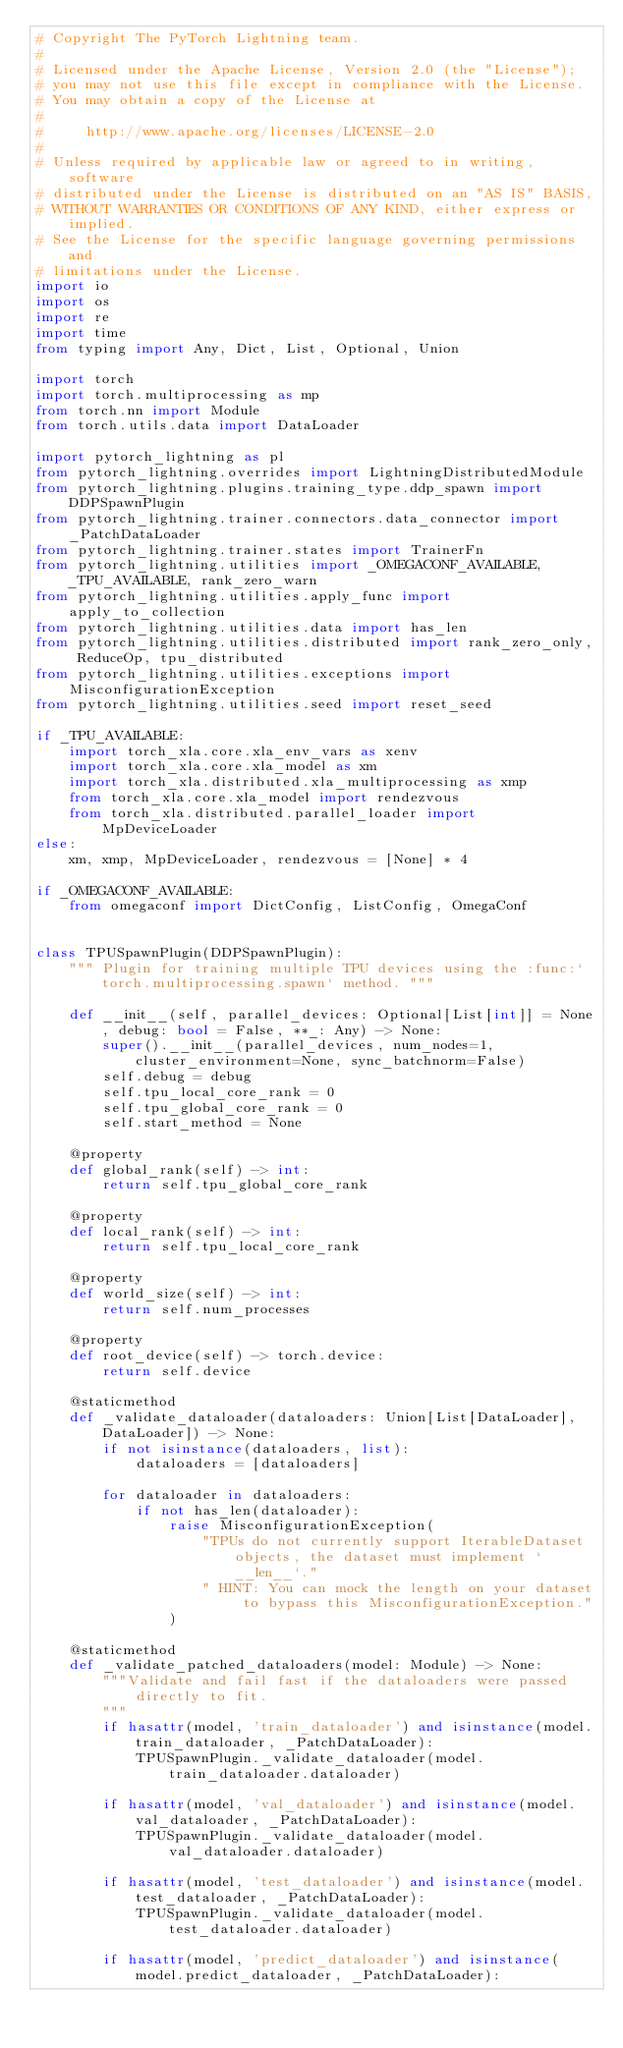<code> <loc_0><loc_0><loc_500><loc_500><_Python_># Copyright The PyTorch Lightning team.
#
# Licensed under the Apache License, Version 2.0 (the "License");
# you may not use this file except in compliance with the License.
# You may obtain a copy of the License at
#
#     http://www.apache.org/licenses/LICENSE-2.0
#
# Unless required by applicable law or agreed to in writing, software
# distributed under the License is distributed on an "AS IS" BASIS,
# WITHOUT WARRANTIES OR CONDITIONS OF ANY KIND, either express or implied.
# See the License for the specific language governing permissions and
# limitations under the License.
import io
import os
import re
import time
from typing import Any, Dict, List, Optional, Union

import torch
import torch.multiprocessing as mp
from torch.nn import Module
from torch.utils.data import DataLoader

import pytorch_lightning as pl
from pytorch_lightning.overrides import LightningDistributedModule
from pytorch_lightning.plugins.training_type.ddp_spawn import DDPSpawnPlugin
from pytorch_lightning.trainer.connectors.data_connector import _PatchDataLoader
from pytorch_lightning.trainer.states import TrainerFn
from pytorch_lightning.utilities import _OMEGACONF_AVAILABLE, _TPU_AVAILABLE, rank_zero_warn
from pytorch_lightning.utilities.apply_func import apply_to_collection
from pytorch_lightning.utilities.data import has_len
from pytorch_lightning.utilities.distributed import rank_zero_only, ReduceOp, tpu_distributed
from pytorch_lightning.utilities.exceptions import MisconfigurationException
from pytorch_lightning.utilities.seed import reset_seed

if _TPU_AVAILABLE:
    import torch_xla.core.xla_env_vars as xenv
    import torch_xla.core.xla_model as xm
    import torch_xla.distributed.xla_multiprocessing as xmp
    from torch_xla.core.xla_model import rendezvous
    from torch_xla.distributed.parallel_loader import MpDeviceLoader
else:
    xm, xmp, MpDeviceLoader, rendezvous = [None] * 4

if _OMEGACONF_AVAILABLE:
    from omegaconf import DictConfig, ListConfig, OmegaConf


class TPUSpawnPlugin(DDPSpawnPlugin):
    """ Plugin for training multiple TPU devices using the :func:`torch.multiprocessing.spawn` method. """

    def __init__(self, parallel_devices: Optional[List[int]] = None, debug: bool = False, **_: Any) -> None:
        super().__init__(parallel_devices, num_nodes=1, cluster_environment=None, sync_batchnorm=False)
        self.debug = debug
        self.tpu_local_core_rank = 0
        self.tpu_global_core_rank = 0
        self.start_method = None

    @property
    def global_rank(self) -> int:
        return self.tpu_global_core_rank

    @property
    def local_rank(self) -> int:
        return self.tpu_local_core_rank

    @property
    def world_size(self) -> int:
        return self.num_processes

    @property
    def root_device(self) -> torch.device:
        return self.device

    @staticmethod
    def _validate_dataloader(dataloaders: Union[List[DataLoader], DataLoader]) -> None:
        if not isinstance(dataloaders, list):
            dataloaders = [dataloaders]

        for dataloader in dataloaders:
            if not has_len(dataloader):
                raise MisconfigurationException(
                    "TPUs do not currently support IterableDataset objects, the dataset must implement `__len__`."
                    " HINT: You can mock the length on your dataset to bypass this MisconfigurationException."
                )

    @staticmethod
    def _validate_patched_dataloaders(model: Module) -> None:
        """Validate and fail fast if the dataloaders were passed directly to fit.
        """
        if hasattr(model, 'train_dataloader') and isinstance(model.train_dataloader, _PatchDataLoader):
            TPUSpawnPlugin._validate_dataloader(model.train_dataloader.dataloader)

        if hasattr(model, 'val_dataloader') and isinstance(model.val_dataloader, _PatchDataLoader):
            TPUSpawnPlugin._validate_dataloader(model.val_dataloader.dataloader)

        if hasattr(model, 'test_dataloader') and isinstance(model.test_dataloader, _PatchDataLoader):
            TPUSpawnPlugin._validate_dataloader(model.test_dataloader.dataloader)

        if hasattr(model, 'predict_dataloader') and isinstance(model.predict_dataloader, _PatchDataLoader):</code> 